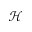Convert formula to latex. <formula><loc_0><loc_0><loc_500><loc_500>\mathcal { H }</formula> 